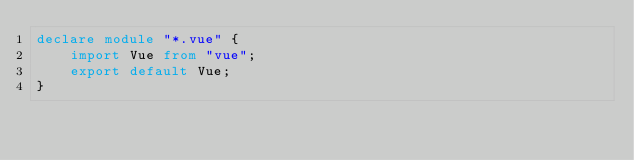<code> <loc_0><loc_0><loc_500><loc_500><_TypeScript_>declare module "*.vue" {
    import Vue from "vue";
    export default Vue;
}</code> 